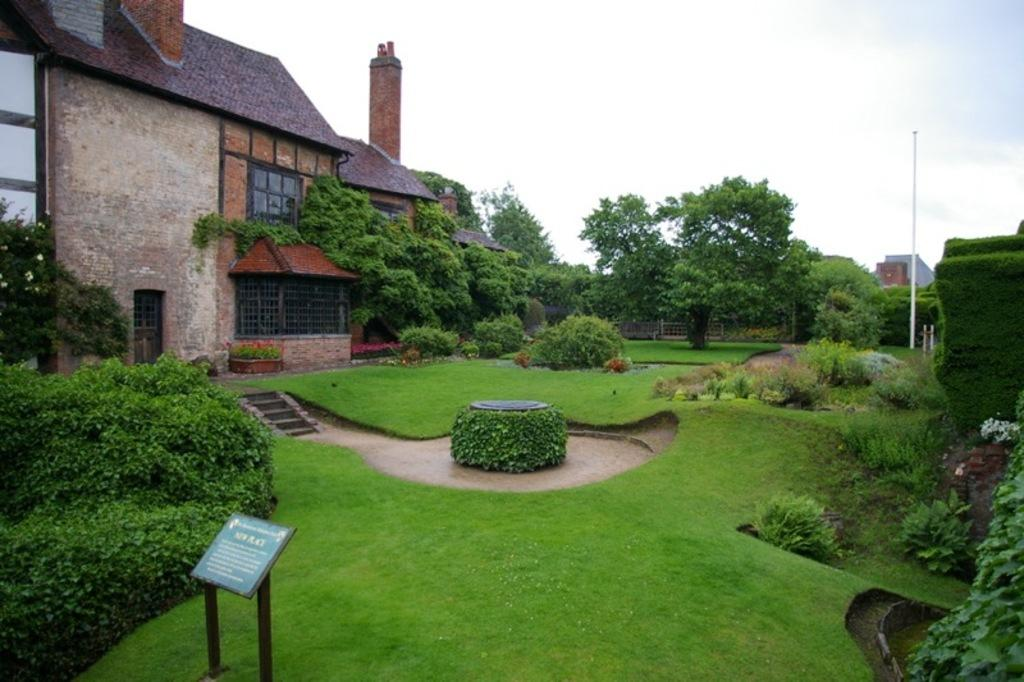What type of vegetation can be seen in the image? There are trees and plants in the image. What is written on the board in the image? There is a board with text in the image, but the specific text is not mentioned in the facts. What is the ground covered with in the image? There is grass on the ground in the image. What structure is present in the image? There is a pole in the image. What type of structures can be seen in the image? There are buildings in the image. What is the condition of the sky in the image? The sky is cloudy in the image. What architectural feature is present in the image? There are stairs in the image. How does the growth of the trees affect the copy of the document on the board? There is no mention of a document or its copy in the image, and the growth of the trees does not affect any document. 